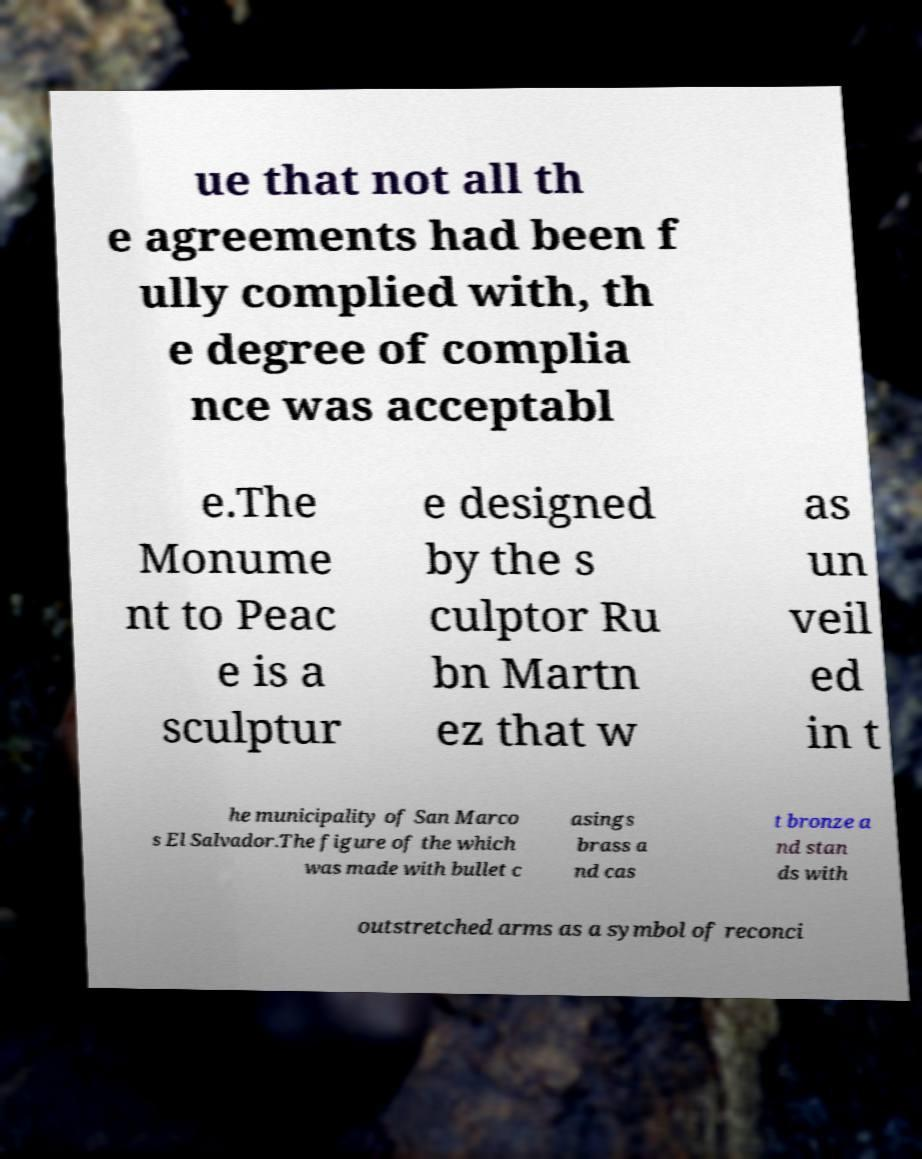Please identify and transcribe the text found in this image. ue that not all th e agreements had been f ully complied with, th e degree of complia nce was acceptabl e.The Monume nt to Peac e is a sculptur e designed by the s culptor Ru bn Martn ez that w as un veil ed in t he municipality of San Marco s El Salvador.The figure of the which was made with bullet c asings brass a nd cas t bronze a nd stan ds with outstretched arms as a symbol of reconci 